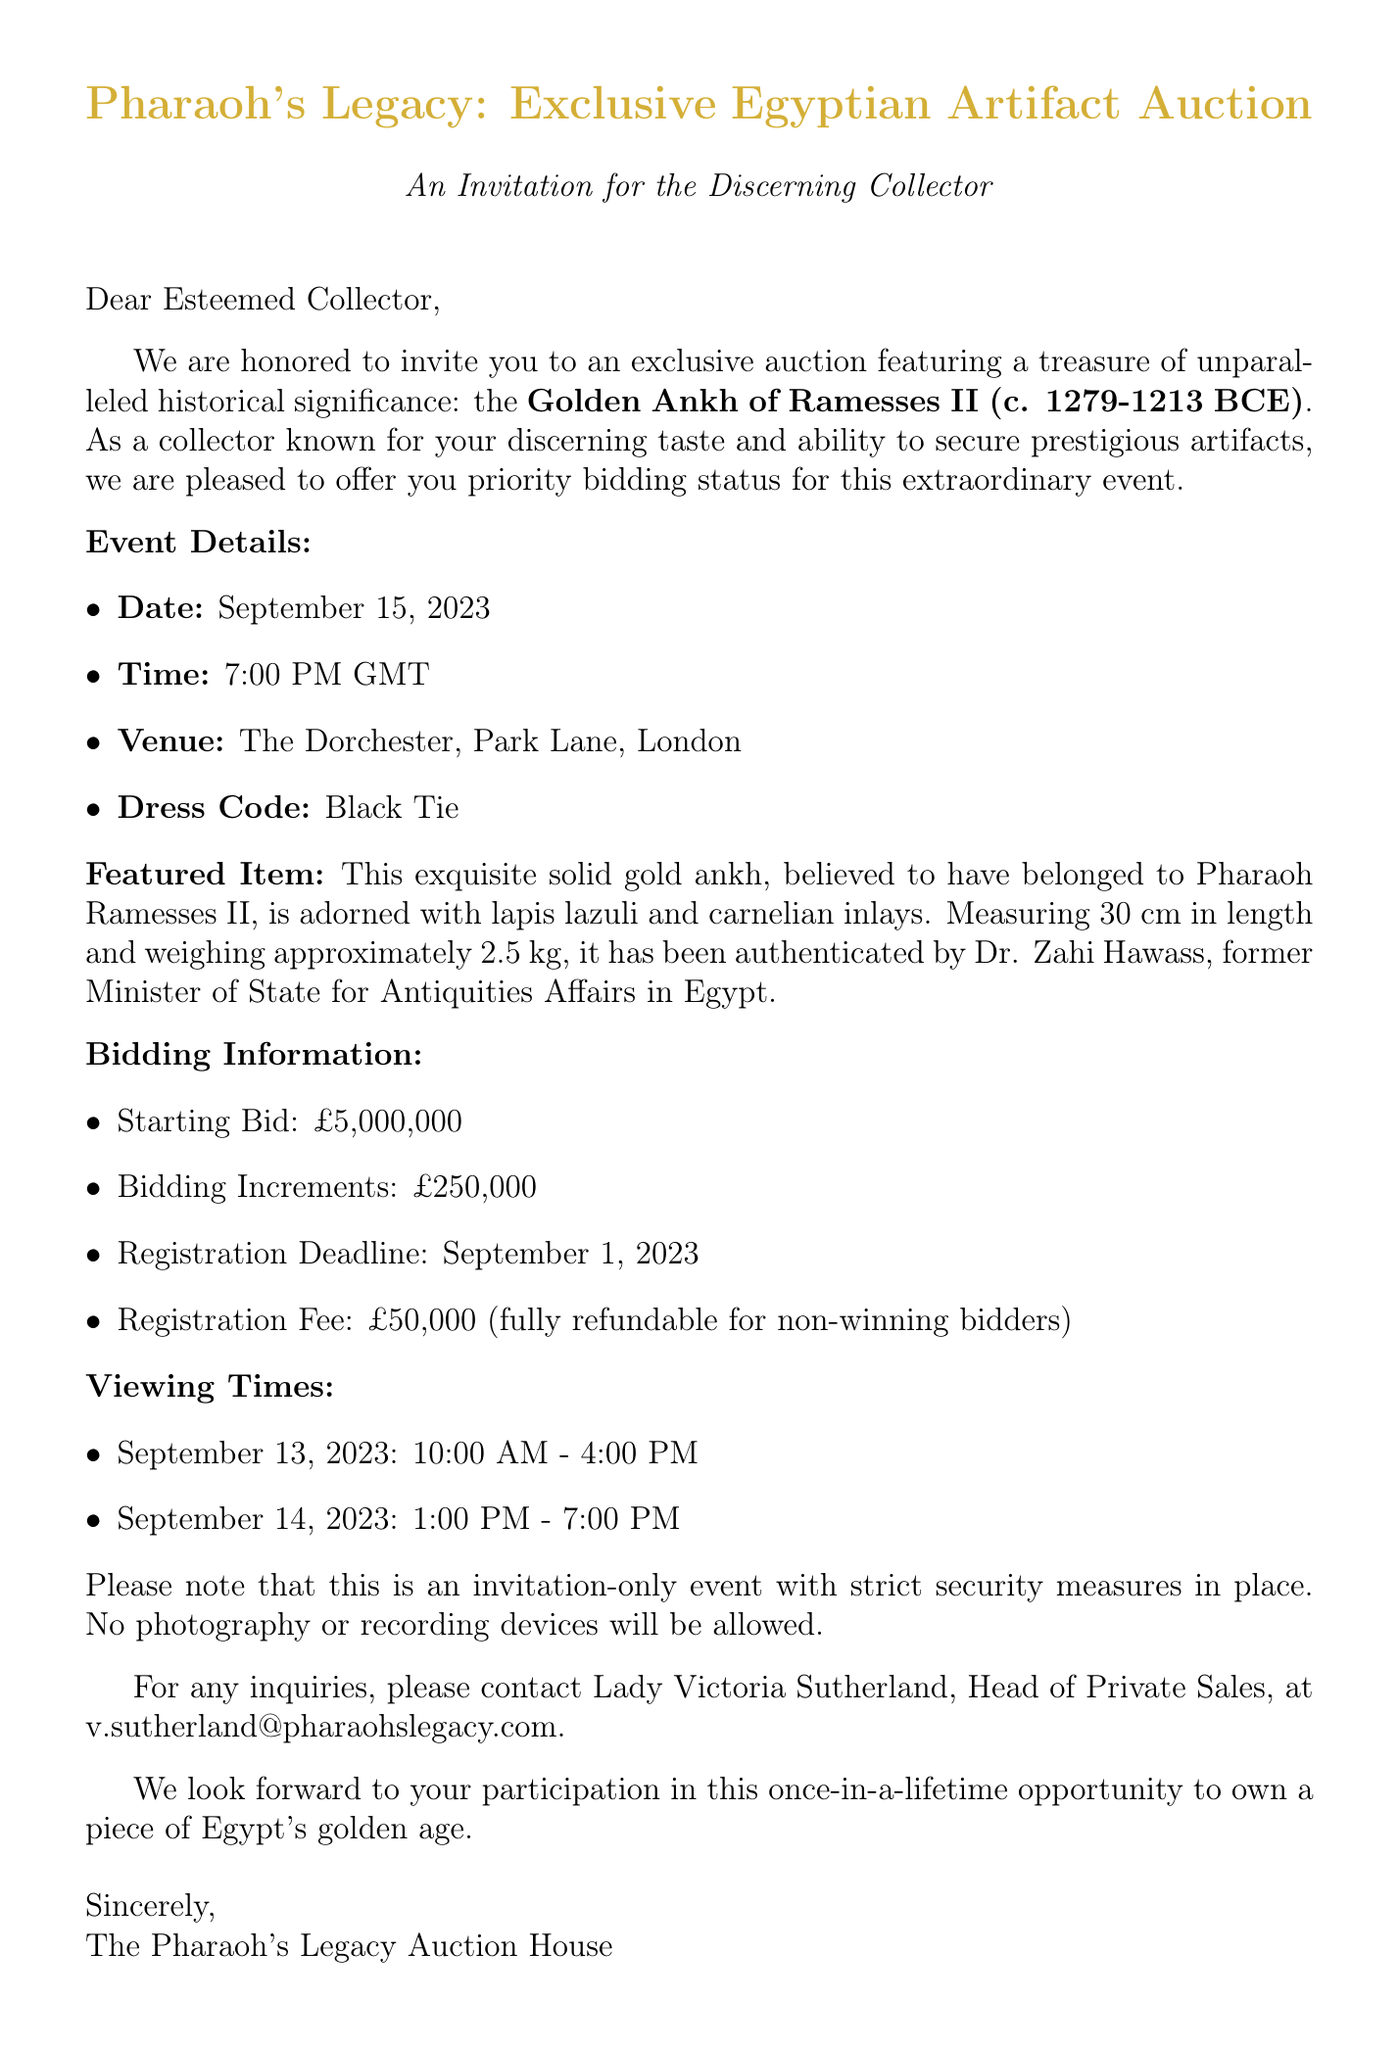What is the date of the auction? The date of the auction is specifically mentioned in the document as September 15, 2023.
Answer: September 15, 2023 What is the starting bid for the featured item? The document explicitly states the starting bid, which is £5,000,000.
Answer: £5,000,000 Who authenticated the Golden Ankh of Ramesses II? The document lists Dr. Zahi Hawass as the authority who authenticated the artifact.
Answer: Dr. Zahi Hawass What is the registration deadline for bidders? The deadline for registration is noted in the document as September 1, 2023.
Answer: September 1, 2023 What is the dress code for the event? The document mentions that the dress code for the auction is Black Tie.
Answer: Black Tie What is the venue for the auction? The document specifies that the auction will be held at The Dorchester, Park Lane, London.
Answer: The Dorchester, Park Lane, London How much is the registration fee? The registration fee is clearly stated in the document as £50,000.
Answer: £50,000 What are the security measures for the event? The document lists several security measures including invitation-only status and strict identity verification.
Answer: Invitation-only event, strict identity verification What are the viewing times for the artifact? The document outlines specific times for viewing the artifact on September 13 and 14, 2023.
Answer: September 13, 2023: 10:00 AM - 4:00 PM; September 14, 2023: 1:00 PM - 7:00 PM Who should be contacted for inquiries? The document directs inquiries to Lady Victoria Sutherland, Head of Private Sales.
Answer: Lady Victoria Sutherland 